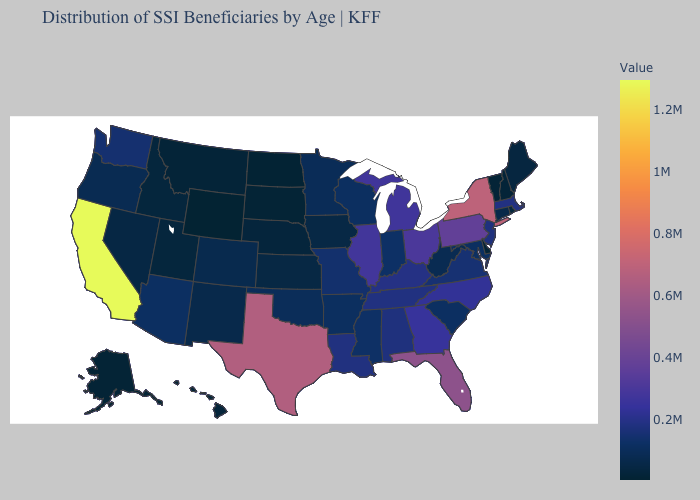Does California have the highest value in the USA?
Keep it brief. Yes. Among the states that border Alabama , which have the highest value?
Give a very brief answer. Florida. 